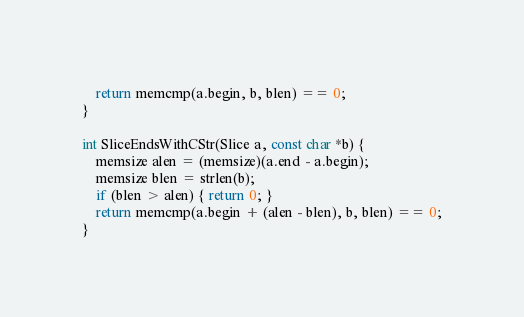Convert code to text. <code><loc_0><loc_0><loc_500><loc_500><_C_>    return memcmp(a.begin, b, blen) == 0;
}

int SliceEndsWithCStr(Slice a, const char *b) {
    memsize alen = (memsize)(a.end - a.begin);
    memsize blen = strlen(b);
    if (blen > alen) { return 0; }
    return memcmp(a.begin + (alen - blen), b, blen) == 0;
}

</code> 